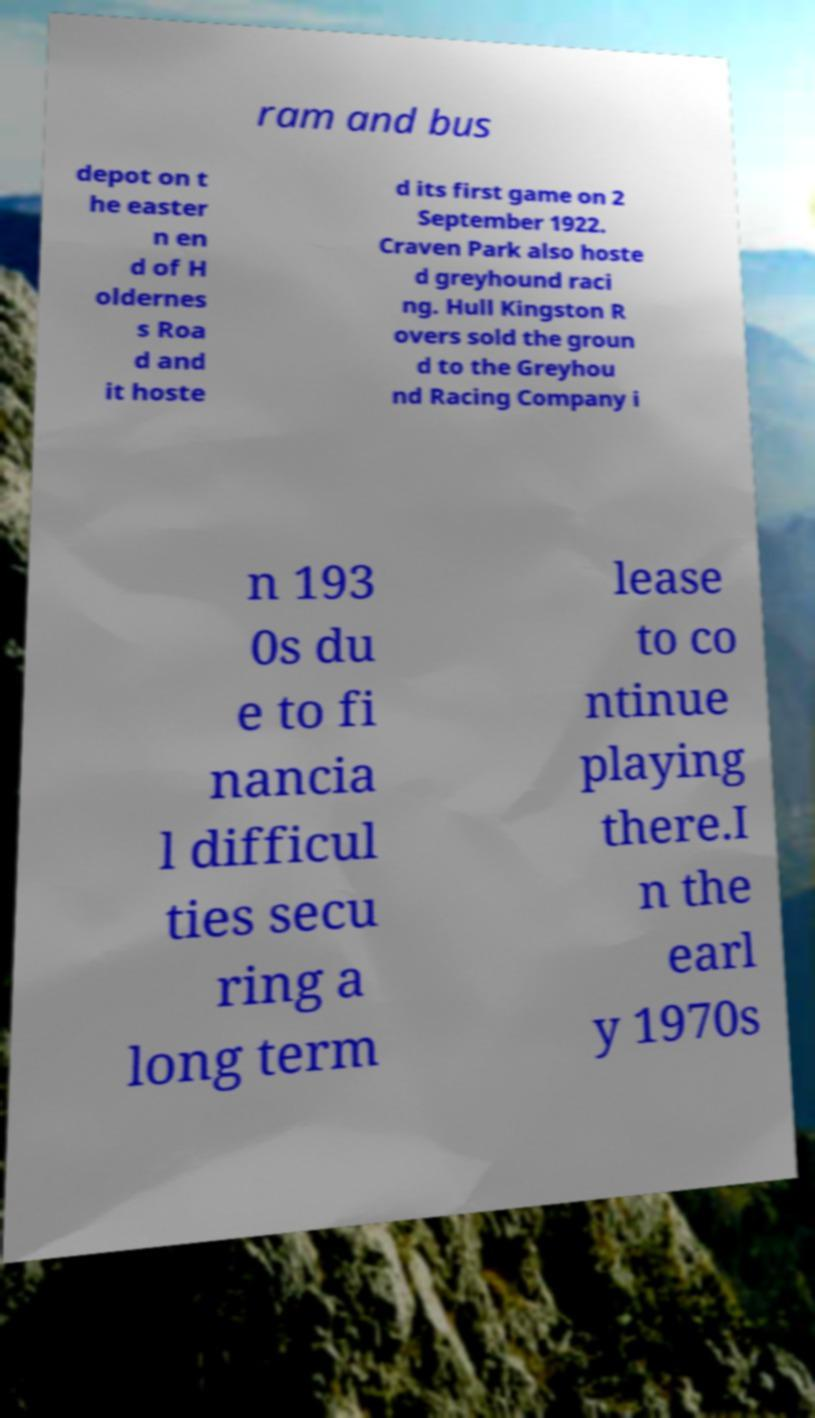Please identify and transcribe the text found in this image. ram and bus depot on t he easter n en d of H oldernes s Roa d and it hoste d its first game on 2 September 1922. Craven Park also hoste d greyhound raci ng. Hull Kingston R overs sold the groun d to the Greyhou nd Racing Company i n 193 0s du e to fi nancia l difficul ties secu ring a long term lease to co ntinue playing there.I n the earl y 1970s 